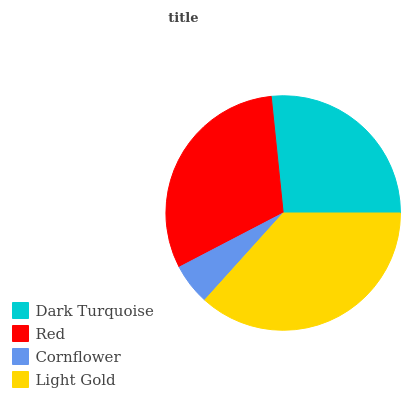Is Cornflower the minimum?
Answer yes or no. Yes. Is Light Gold the maximum?
Answer yes or no. Yes. Is Red the minimum?
Answer yes or no. No. Is Red the maximum?
Answer yes or no. No. Is Red greater than Dark Turquoise?
Answer yes or no. Yes. Is Dark Turquoise less than Red?
Answer yes or no. Yes. Is Dark Turquoise greater than Red?
Answer yes or no. No. Is Red less than Dark Turquoise?
Answer yes or no. No. Is Red the high median?
Answer yes or no. Yes. Is Dark Turquoise the low median?
Answer yes or no. Yes. Is Light Gold the high median?
Answer yes or no. No. Is Cornflower the low median?
Answer yes or no. No. 